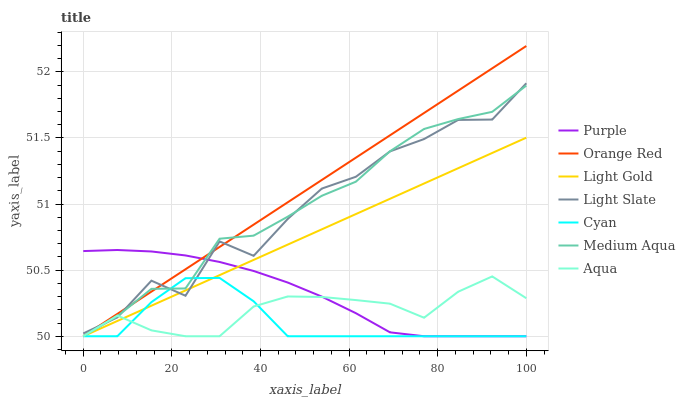Does Cyan have the minimum area under the curve?
Answer yes or no. Yes. Does Orange Red have the maximum area under the curve?
Answer yes or no. Yes. Does Aqua have the minimum area under the curve?
Answer yes or no. No. Does Aqua have the maximum area under the curve?
Answer yes or no. No. Is Orange Red the smoothest?
Answer yes or no. Yes. Is Light Slate the roughest?
Answer yes or no. Yes. Is Aqua the smoothest?
Answer yes or no. No. Is Aqua the roughest?
Answer yes or no. No. Does Purple have the lowest value?
Answer yes or no. Yes. Does Light Slate have the lowest value?
Answer yes or no. No. Does Orange Red have the highest value?
Answer yes or no. Yes. Does Aqua have the highest value?
Answer yes or no. No. Does Light Gold intersect Aqua?
Answer yes or no. Yes. Is Light Gold less than Aqua?
Answer yes or no. No. Is Light Gold greater than Aqua?
Answer yes or no. No. 